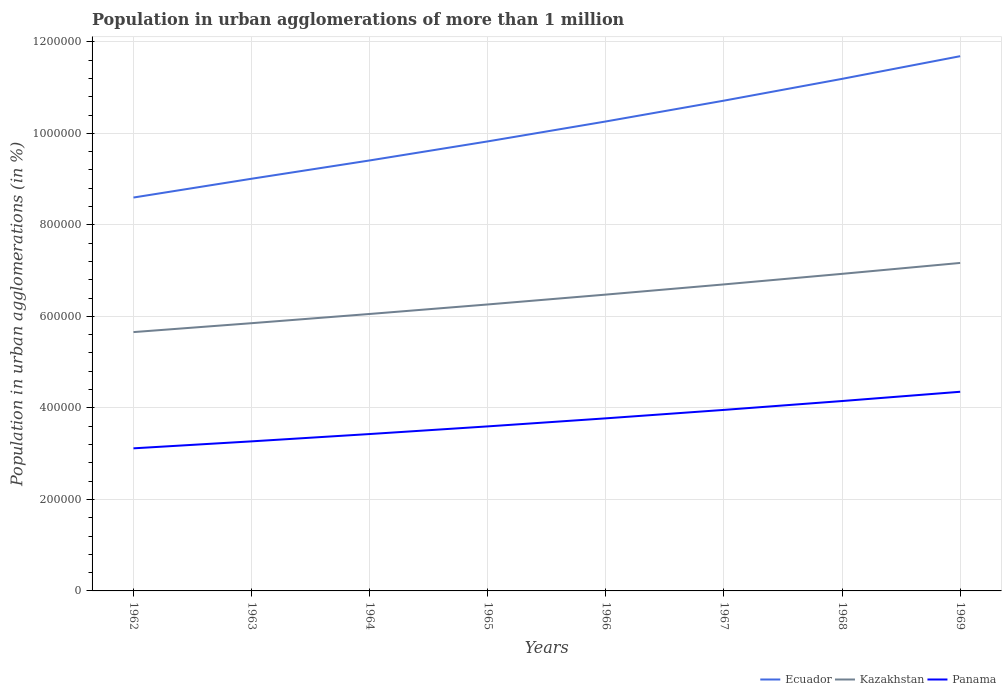Across all years, what is the maximum population in urban agglomerations in Kazakhstan?
Ensure brevity in your answer.  5.66e+05. In which year was the population in urban agglomerations in Ecuador maximum?
Your answer should be very brief. 1962. What is the total population in urban agglomerations in Kazakhstan in the graph?
Your answer should be very brief. -2.15e+04. What is the difference between the highest and the second highest population in urban agglomerations in Panama?
Give a very brief answer. 1.24e+05. What is the difference between the highest and the lowest population in urban agglomerations in Panama?
Keep it short and to the point. 4. Is the population in urban agglomerations in Panama strictly greater than the population in urban agglomerations in Kazakhstan over the years?
Your answer should be very brief. Yes. How many lines are there?
Ensure brevity in your answer.  3. How many years are there in the graph?
Provide a short and direct response. 8. Does the graph contain any zero values?
Your answer should be compact. No. Where does the legend appear in the graph?
Give a very brief answer. Bottom right. What is the title of the graph?
Your answer should be very brief. Population in urban agglomerations of more than 1 million. What is the label or title of the Y-axis?
Ensure brevity in your answer.  Population in urban agglomerations (in %). What is the Population in urban agglomerations (in %) of Ecuador in 1962?
Provide a short and direct response. 8.60e+05. What is the Population in urban agglomerations (in %) in Kazakhstan in 1962?
Make the answer very short. 5.66e+05. What is the Population in urban agglomerations (in %) of Panama in 1962?
Provide a short and direct response. 3.12e+05. What is the Population in urban agglomerations (in %) of Ecuador in 1963?
Your answer should be very brief. 9.01e+05. What is the Population in urban agglomerations (in %) in Kazakhstan in 1963?
Offer a terse response. 5.85e+05. What is the Population in urban agglomerations (in %) of Panama in 1963?
Provide a short and direct response. 3.27e+05. What is the Population in urban agglomerations (in %) of Ecuador in 1964?
Give a very brief answer. 9.41e+05. What is the Population in urban agglomerations (in %) in Kazakhstan in 1964?
Ensure brevity in your answer.  6.05e+05. What is the Population in urban agglomerations (in %) in Panama in 1964?
Ensure brevity in your answer.  3.43e+05. What is the Population in urban agglomerations (in %) in Ecuador in 1965?
Provide a short and direct response. 9.82e+05. What is the Population in urban agglomerations (in %) in Kazakhstan in 1965?
Provide a short and direct response. 6.26e+05. What is the Population in urban agglomerations (in %) in Panama in 1965?
Offer a terse response. 3.60e+05. What is the Population in urban agglomerations (in %) in Ecuador in 1966?
Your response must be concise. 1.03e+06. What is the Population in urban agglomerations (in %) of Kazakhstan in 1966?
Your answer should be very brief. 6.48e+05. What is the Population in urban agglomerations (in %) of Panama in 1966?
Offer a terse response. 3.77e+05. What is the Population in urban agglomerations (in %) of Ecuador in 1967?
Your response must be concise. 1.07e+06. What is the Population in urban agglomerations (in %) of Kazakhstan in 1967?
Your answer should be compact. 6.70e+05. What is the Population in urban agglomerations (in %) of Panama in 1967?
Provide a short and direct response. 3.96e+05. What is the Population in urban agglomerations (in %) of Ecuador in 1968?
Offer a terse response. 1.12e+06. What is the Population in urban agglomerations (in %) of Kazakhstan in 1968?
Make the answer very short. 6.93e+05. What is the Population in urban agglomerations (in %) of Panama in 1968?
Your answer should be very brief. 4.15e+05. What is the Population in urban agglomerations (in %) in Ecuador in 1969?
Offer a very short reply. 1.17e+06. What is the Population in urban agglomerations (in %) of Kazakhstan in 1969?
Give a very brief answer. 7.17e+05. What is the Population in urban agglomerations (in %) in Panama in 1969?
Make the answer very short. 4.35e+05. Across all years, what is the maximum Population in urban agglomerations (in %) of Ecuador?
Your answer should be very brief. 1.17e+06. Across all years, what is the maximum Population in urban agglomerations (in %) in Kazakhstan?
Offer a terse response. 7.17e+05. Across all years, what is the maximum Population in urban agglomerations (in %) in Panama?
Offer a terse response. 4.35e+05. Across all years, what is the minimum Population in urban agglomerations (in %) of Ecuador?
Your response must be concise. 8.60e+05. Across all years, what is the minimum Population in urban agglomerations (in %) of Kazakhstan?
Your response must be concise. 5.66e+05. Across all years, what is the minimum Population in urban agglomerations (in %) of Panama?
Provide a succinct answer. 3.12e+05. What is the total Population in urban agglomerations (in %) in Ecuador in the graph?
Provide a succinct answer. 8.07e+06. What is the total Population in urban agglomerations (in %) of Kazakhstan in the graph?
Offer a terse response. 5.11e+06. What is the total Population in urban agglomerations (in %) of Panama in the graph?
Your answer should be very brief. 2.96e+06. What is the difference between the Population in urban agglomerations (in %) of Ecuador in 1962 and that in 1963?
Your response must be concise. -4.11e+04. What is the difference between the Population in urban agglomerations (in %) of Kazakhstan in 1962 and that in 1963?
Your response must be concise. -1.95e+04. What is the difference between the Population in urban agglomerations (in %) in Panama in 1962 and that in 1963?
Provide a succinct answer. -1.52e+04. What is the difference between the Population in urban agglomerations (in %) of Ecuador in 1962 and that in 1964?
Give a very brief answer. -8.11e+04. What is the difference between the Population in urban agglomerations (in %) in Kazakhstan in 1962 and that in 1964?
Give a very brief answer. -3.96e+04. What is the difference between the Population in urban agglomerations (in %) of Panama in 1962 and that in 1964?
Provide a succinct answer. -3.12e+04. What is the difference between the Population in urban agglomerations (in %) of Ecuador in 1962 and that in 1965?
Give a very brief answer. -1.23e+05. What is the difference between the Population in urban agglomerations (in %) of Kazakhstan in 1962 and that in 1965?
Your answer should be compact. -6.04e+04. What is the difference between the Population in urban agglomerations (in %) of Panama in 1962 and that in 1965?
Your answer should be very brief. -4.80e+04. What is the difference between the Population in urban agglomerations (in %) of Ecuador in 1962 and that in 1966?
Your response must be concise. -1.66e+05. What is the difference between the Population in urban agglomerations (in %) in Kazakhstan in 1962 and that in 1966?
Keep it short and to the point. -8.19e+04. What is the difference between the Population in urban agglomerations (in %) in Panama in 1962 and that in 1966?
Give a very brief answer. -6.56e+04. What is the difference between the Population in urban agglomerations (in %) of Ecuador in 1962 and that in 1967?
Offer a very short reply. -2.12e+05. What is the difference between the Population in urban agglomerations (in %) in Kazakhstan in 1962 and that in 1967?
Offer a terse response. -1.04e+05. What is the difference between the Population in urban agglomerations (in %) in Panama in 1962 and that in 1967?
Your answer should be compact. -8.40e+04. What is the difference between the Population in urban agglomerations (in %) in Ecuador in 1962 and that in 1968?
Provide a short and direct response. -2.59e+05. What is the difference between the Population in urban agglomerations (in %) of Kazakhstan in 1962 and that in 1968?
Offer a terse response. -1.27e+05. What is the difference between the Population in urban agglomerations (in %) of Panama in 1962 and that in 1968?
Your response must be concise. -1.03e+05. What is the difference between the Population in urban agglomerations (in %) of Ecuador in 1962 and that in 1969?
Make the answer very short. -3.09e+05. What is the difference between the Population in urban agglomerations (in %) in Kazakhstan in 1962 and that in 1969?
Your answer should be compact. -1.51e+05. What is the difference between the Population in urban agglomerations (in %) of Panama in 1962 and that in 1969?
Provide a short and direct response. -1.24e+05. What is the difference between the Population in urban agglomerations (in %) of Ecuador in 1963 and that in 1964?
Give a very brief answer. -4.00e+04. What is the difference between the Population in urban agglomerations (in %) of Kazakhstan in 1963 and that in 1964?
Offer a terse response. -2.02e+04. What is the difference between the Population in urban agglomerations (in %) in Panama in 1963 and that in 1964?
Make the answer very short. -1.60e+04. What is the difference between the Population in urban agglomerations (in %) in Ecuador in 1963 and that in 1965?
Your answer should be compact. -8.16e+04. What is the difference between the Population in urban agglomerations (in %) in Kazakhstan in 1963 and that in 1965?
Offer a terse response. -4.09e+04. What is the difference between the Population in urban agglomerations (in %) in Panama in 1963 and that in 1965?
Make the answer very short. -3.27e+04. What is the difference between the Population in urban agglomerations (in %) in Ecuador in 1963 and that in 1966?
Keep it short and to the point. -1.25e+05. What is the difference between the Population in urban agglomerations (in %) in Kazakhstan in 1963 and that in 1966?
Offer a terse response. -6.25e+04. What is the difference between the Population in urban agglomerations (in %) of Panama in 1963 and that in 1966?
Keep it short and to the point. -5.03e+04. What is the difference between the Population in urban agglomerations (in %) in Ecuador in 1963 and that in 1967?
Your answer should be very brief. -1.71e+05. What is the difference between the Population in urban agglomerations (in %) of Kazakhstan in 1963 and that in 1967?
Provide a succinct answer. -8.48e+04. What is the difference between the Population in urban agglomerations (in %) of Panama in 1963 and that in 1967?
Your response must be concise. -6.88e+04. What is the difference between the Population in urban agglomerations (in %) in Ecuador in 1963 and that in 1968?
Provide a short and direct response. -2.18e+05. What is the difference between the Population in urban agglomerations (in %) of Kazakhstan in 1963 and that in 1968?
Give a very brief answer. -1.08e+05. What is the difference between the Population in urban agglomerations (in %) in Panama in 1963 and that in 1968?
Ensure brevity in your answer.  -8.81e+04. What is the difference between the Population in urban agglomerations (in %) in Ecuador in 1963 and that in 1969?
Provide a short and direct response. -2.68e+05. What is the difference between the Population in urban agglomerations (in %) in Kazakhstan in 1963 and that in 1969?
Offer a very short reply. -1.32e+05. What is the difference between the Population in urban agglomerations (in %) of Panama in 1963 and that in 1969?
Give a very brief answer. -1.08e+05. What is the difference between the Population in urban agglomerations (in %) in Ecuador in 1964 and that in 1965?
Keep it short and to the point. -4.17e+04. What is the difference between the Population in urban agglomerations (in %) in Kazakhstan in 1964 and that in 1965?
Your response must be concise. -2.08e+04. What is the difference between the Population in urban agglomerations (in %) in Panama in 1964 and that in 1965?
Give a very brief answer. -1.67e+04. What is the difference between the Population in urban agglomerations (in %) in Ecuador in 1964 and that in 1966?
Your answer should be compact. -8.52e+04. What is the difference between the Population in urban agglomerations (in %) of Kazakhstan in 1964 and that in 1966?
Provide a succinct answer. -4.23e+04. What is the difference between the Population in urban agglomerations (in %) in Panama in 1964 and that in 1966?
Your answer should be compact. -3.43e+04. What is the difference between the Population in urban agglomerations (in %) in Ecuador in 1964 and that in 1967?
Keep it short and to the point. -1.31e+05. What is the difference between the Population in urban agglomerations (in %) of Kazakhstan in 1964 and that in 1967?
Keep it short and to the point. -6.46e+04. What is the difference between the Population in urban agglomerations (in %) of Panama in 1964 and that in 1967?
Keep it short and to the point. -5.28e+04. What is the difference between the Population in urban agglomerations (in %) of Ecuador in 1964 and that in 1968?
Keep it short and to the point. -1.78e+05. What is the difference between the Population in urban agglomerations (in %) in Kazakhstan in 1964 and that in 1968?
Offer a terse response. -8.77e+04. What is the difference between the Population in urban agglomerations (in %) in Panama in 1964 and that in 1968?
Your response must be concise. -7.21e+04. What is the difference between the Population in urban agglomerations (in %) in Ecuador in 1964 and that in 1969?
Give a very brief answer. -2.28e+05. What is the difference between the Population in urban agglomerations (in %) of Kazakhstan in 1964 and that in 1969?
Provide a succinct answer. -1.11e+05. What is the difference between the Population in urban agglomerations (in %) of Panama in 1964 and that in 1969?
Offer a very short reply. -9.24e+04. What is the difference between the Population in urban agglomerations (in %) in Ecuador in 1965 and that in 1966?
Provide a short and direct response. -4.36e+04. What is the difference between the Population in urban agglomerations (in %) of Kazakhstan in 1965 and that in 1966?
Ensure brevity in your answer.  -2.15e+04. What is the difference between the Population in urban agglomerations (in %) in Panama in 1965 and that in 1966?
Your answer should be compact. -1.76e+04. What is the difference between the Population in urban agglomerations (in %) in Ecuador in 1965 and that in 1967?
Offer a terse response. -8.91e+04. What is the difference between the Population in urban agglomerations (in %) in Kazakhstan in 1965 and that in 1967?
Your response must be concise. -4.38e+04. What is the difference between the Population in urban agglomerations (in %) of Panama in 1965 and that in 1967?
Your answer should be very brief. -3.60e+04. What is the difference between the Population in urban agglomerations (in %) of Ecuador in 1965 and that in 1968?
Make the answer very short. -1.37e+05. What is the difference between the Population in urban agglomerations (in %) in Kazakhstan in 1965 and that in 1968?
Your answer should be compact. -6.69e+04. What is the difference between the Population in urban agglomerations (in %) of Panama in 1965 and that in 1968?
Provide a succinct answer. -5.54e+04. What is the difference between the Population in urban agglomerations (in %) of Ecuador in 1965 and that in 1969?
Provide a succinct answer. -1.86e+05. What is the difference between the Population in urban agglomerations (in %) of Kazakhstan in 1965 and that in 1969?
Provide a succinct answer. -9.07e+04. What is the difference between the Population in urban agglomerations (in %) in Panama in 1965 and that in 1969?
Your answer should be very brief. -7.57e+04. What is the difference between the Population in urban agglomerations (in %) in Ecuador in 1966 and that in 1967?
Offer a terse response. -4.55e+04. What is the difference between the Population in urban agglomerations (in %) of Kazakhstan in 1966 and that in 1967?
Your response must be concise. -2.23e+04. What is the difference between the Population in urban agglomerations (in %) in Panama in 1966 and that in 1967?
Your response must be concise. -1.84e+04. What is the difference between the Population in urban agglomerations (in %) of Ecuador in 1966 and that in 1968?
Your response must be concise. -9.31e+04. What is the difference between the Population in urban agglomerations (in %) in Kazakhstan in 1966 and that in 1968?
Give a very brief answer. -4.54e+04. What is the difference between the Population in urban agglomerations (in %) of Panama in 1966 and that in 1968?
Offer a very short reply. -3.78e+04. What is the difference between the Population in urban agglomerations (in %) in Ecuador in 1966 and that in 1969?
Offer a very short reply. -1.43e+05. What is the difference between the Population in urban agglomerations (in %) in Kazakhstan in 1966 and that in 1969?
Offer a terse response. -6.92e+04. What is the difference between the Population in urban agglomerations (in %) in Panama in 1966 and that in 1969?
Provide a succinct answer. -5.81e+04. What is the difference between the Population in urban agglomerations (in %) of Ecuador in 1967 and that in 1968?
Your response must be concise. -4.76e+04. What is the difference between the Population in urban agglomerations (in %) of Kazakhstan in 1967 and that in 1968?
Your answer should be compact. -2.31e+04. What is the difference between the Population in urban agglomerations (in %) of Panama in 1967 and that in 1968?
Your answer should be compact. -1.94e+04. What is the difference between the Population in urban agglomerations (in %) in Ecuador in 1967 and that in 1969?
Give a very brief answer. -9.71e+04. What is the difference between the Population in urban agglomerations (in %) in Kazakhstan in 1967 and that in 1969?
Offer a terse response. -4.69e+04. What is the difference between the Population in urban agglomerations (in %) of Panama in 1967 and that in 1969?
Keep it short and to the point. -3.96e+04. What is the difference between the Population in urban agglomerations (in %) of Ecuador in 1968 and that in 1969?
Your answer should be compact. -4.96e+04. What is the difference between the Population in urban agglomerations (in %) in Kazakhstan in 1968 and that in 1969?
Your answer should be compact. -2.38e+04. What is the difference between the Population in urban agglomerations (in %) of Panama in 1968 and that in 1969?
Your answer should be compact. -2.03e+04. What is the difference between the Population in urban agglomerations (in %) of Ecuador in 1962 and the Population in urban agglomerations (in %) of Kazakhstan in 1963?
Your answer should be very brief. 2.75e+05. What is the difference between the Population in urban agglomerations (in %) of Ecuador in 1962 and the Population in urban agglomerations (in %) of Panama in 1963?
Provide a succinct answer. 5.33e+05. What is the difference between the Population in urban agglomerations (in %) of Kazakhstan in 1962 and the Population in urban agglomerations (in %) of Panama in 1963?
Your response must be concise. 2.39e+05. What is the difference between the Population in urban agglomerations (in %) in Ecuador in 1962 and the Population in urban agglomerations (in %) in Kazakhstan in 1964?
Offer a terse response. 2.54e+05. What is the difference between the Population in urban agglomerations (in %) of Ecuador in 1962 and the Population in urban agglomerations (in %) of Panama in 1964?
Keep it short and to the point. 5.17e+05. What is the difference between the Population in urban agglomerations (in %) in Kazakhstan in 1962 and the Population in urban agglomerations (in %) in Panama in 1964?
Make the answer very short. 2.23e+05. What is the difference between the Population in urban agglomerations (in %) of Ecuador in 1962 and the Population in urban agglomerations (in %) of Kazakhstan in 1965?
Give a very brief answer. 2.34e+05. What is the difference between the Population in urban agglomerations (in %) of Ecuador in 1962 and the Population in urban agglomerations (in %) of Panama in 1965?
Provide a succinct answer. 5.00e+05. What is the difference between the Population in urban agglomerations (in %) of Kazakhstan in 1962 and the Population in urban agglomerations (in %) of Panama in 1965?
Your answer should be very brief. 2.06e+05. What is the difference between the Population in urban agglomerations (in %) in Ecuador in 1962 and the Population in urban agglomerations (in %) in Kazakhstan in 1966?
Make the answer very short. 2.12e+05. What is the difference between the Population in urban agglomerations (in %) of Ecuador in 1962 and the Population in urban agglomerations (in %) of Panama in 1966?
Your response must be concise. 4.83e+05. What is the difference between the Population in urban agglomerations (in %) of Kazakhstan in 1962 and the Population in urban agglomerations (in %) of Panama in 1966?
Your response must be concise. 1.88e+05. What is the difference between the Population in urban agglomerations (in %) of Ecuador in 1962 and the Population in urban agglomerations (in %) of Kazakhstan in 1967?
Your response must be concise. 1.90e+05. What is the difference between the Population in urban agglomerations (in %) in Ecuador in 1962 and the Population in urban agglomerations (in %) in Panama in 1967?
Your response must be concise. 4.64e+05. What is the difference between the Population in urban agglomerations (in %) in Kazakhstan in 1962 and the Population in urban agglomerations (in %) in Panama in 1967?
Offer a terse response. 1.70e+05. What is the difference between the Population in urban agglomerations (in %) of Ecuador in 1962 and the Population in urban agglomerations (in %) of Kazakhstan in 1968?
Give a very brief answer. 1.67e+05. What is the difference between the Population in urban agglomerations (in %) in Ecuador in 1962 and the Population in urban agglomerations (in %) in Panama in 1968?
Keep it short and to the point. 4.45e+05. What is the difference between the Population in urban agglomerations (in %) of Kazakhstan in 1962 and the Population in urban agglomerations (in %) of Panama in 1968?
Provide a succinct answer. 1.51e+05. What is the difference between the Population in urban agglomerations (in %) of Ecuador in 1962 and the Population in urban agglomerations (in %) of Kazakhstan in 1969?
Your answer should be very brief. 1.43e+05. What is the difference between the Population in urban agglomerations (in %) of Ecuador in 1962 and the Population in urban agglomerations (in %) of Panama in 1969?
Your response must be concise. 4.24e+05. What is the difference between the Population in urban agglomerations (in %) in Kazakhstan in 1962 and the Population in urban agglomerations (in %) in Panama in 1969?
Ensure brevity in your answer.  1.30e+05. What is the difference between the Population in urban agglomerations (in %) of Ecuador in 1963 and the Population in urban agglomerations (in %) of Kazakhstan in 1964?
Your answer should be very brief. 2.96e+05. What is the difference between the Population in urban agglomerations (in %) of Ecuador in 1963 and the Population in urban agglomerations (in %) of Panama in 1964?
Ensure brevity in your answer.  5.58e+05. What is the difference between the Population in urban agglomerations (in %) in Kazakhstan in 1963 and the Population in urban agglomerations (in %) in Panama in 1964?
Provide a short and direct response. 2.42e+05. What is the difference between the Population in urban agglomerations (in %) in Ecuador in 1963 and the Population in urban agglomerations (in %) in Kazakhstan in 1965?
Your response must be concise. 2.75e+05. What is the difference between the Population in urban agglomerations (in %) of Ecuador in 1963 and the Population in urban agglomerations (in %) of Panama in 1965?
Make the answer very short. 5.41e+05. What is the difference between the Population in urban agglomerations (in %) in Kazakhstan in 1963 and the Population in urban agglomerations (in %) in Panama in 1965?
Give a very brief answer. 2.26e+05. What is the difference between the Population in urban agglomerations (in %) in Ecuador in 1963 and the Population in urban agglomerations (in %) in Kazakhstan in 1966?
Provide a short and direct response. 2.53e+05. What is the difference between the Population in urban agglomerations (in %) of Ecuador in 1963 and the Population in urban agglomerations (in %) of Panama in 1966?
Offer a very short reply. 5.24e+05. What is the difference between the Population in urban agglomerations (in %) in Kazakhstan in 1963 and the Population in urban agglomerations (in %) in Panama in 1966?
Give a very brief answer. 2.08e+05. What is the difference between the Population in urban agglomerations (in %) in Ecuador in 1963 and the Population in urban agglomerations (in %) in Kazakhstan in 1967?
Your answer should be very brief. 2.31e+05. What is the difference between the Population in urban agglomerations (in %) in Ecuador in 1963 and the Population in urban agglomerations (in %) in Panama in 1967?
Ensure brevity in your answer.  5.05e+05. What is the difference between the Population in urban agglomerations (in %) of Kazakhstan in 1963 and the Population in urban agglomerations (in %) of Panama in 1967?
Offer a terse response. 1.89e+05. What is the difference between the Population in urban agglomerations (in %) of Ecuador in 1963 and the Population in urban agglomerations (in %) of Kazakhstan in 1968?
Your answer should be compact. 2.08e+05. What is the difference between the Population in urban agglomerations (in %) of Ecuador in 1963 and the Population in urban agglomerations (in %) of Panama in 1968?
Make the answer very short. 4.86e+05. What is the difference between the Population in urban agglomerations (in %) of Kazakhstan in 1963 and the Population in urban agglomerations (in %) of Panama in 1968?
Your answer should be very brief. 1.70e+05. What is the difference between the Population in urban agglomerations (in %) in Ecuador in 1963 and the Population in urban agglomerations (in %) in Kazakhstan in 1969?
Give a very brief answer. 1.84e+05. What is the difference between the Population in urban agglomerations (in %) in Ecuador in 1963 and the Population in urban agglomerations (in %) in Panama in 1969?
Provide a succinct answer. 4.66e+05. What is the difference between the Population in urban agglomerations (in %) of Kazakhstan in 1963 and the Population in urban agglomerations (in %) of Panama in 1969?
Provide a succinct answer. 1.50e+05. What is the difference between the Population in urban agglomerations (in %) of Ecuador in 1964 and the Population in urban agglomerations (in %) of Kazakhstan in 1965?
Make the answer very short. 3.15e+05. What is the difference between the Population in urban agglomerations (in %) in Ecuador in 1964 and the Population in urban agglomerations (in %) in Panama in 1965?
Provide a succinct answer. 5.81e+05. What is the difference between the Population in urban agglomerations (in %) in Kazakhstan in 1964 and the Population in urban agglomerations (in %) in Panama in 1965?
Provide a short and direct response. 2.46e+05. What is the difference between the Population in urban agglomerations (in %) in Ecuador in 1964 and the Population in urban agglomerations (in %) in Kazakhstan in 1966?
Provide a short and direct response. 2.93e+05. What is the difference between the Population in urban agglomerations (in %) of Ecuador in 1964 and the Population in urban agglomerations (in %) of Panama in 1966?
Ensure brevity in your answer.  5.64e+05. What is the difference between the Population in urban agglomerations (in %) of Kazakhstan in 1964 and the Population in urban agglomerations (in %) of Panama in 1966?
Your answer should be compact. 2.28e+05. What is the difference between the Population in urban agglomerations (in %) in Ecuador in 1964 and the Population in urban agglomerations (in %) in Kazakhstan in 1967?
Give a very brief answer. 2.71e+05. What is the difference between the Population in urban agglomerations (in %) in Ecuador in 1964 and the Population in urban agglomerations (in %) in Panama in 1967?
Your answer should be very brief. 5.45e+05. What is the difference between the Population in urban agglomerations (in %) in Kazakhstan in 1964 and the Population in urban agglomerations (in %) in Panama in 1967?
Make the answer very short. 2.10e+05. What is the difference between the Population in urban agglomerations (in %) in Ecuador in 1964 and the Population in urban agglomerations (in %) in Kazakhstan in 1968?
Keep it short and to the point. 2.48e+05. What is the difference between the Population in urban agglomerations (in %) of Ecuador in 1964 and the Population in urban agglomerations (in %) of Panama in 1968?
Your response must be concise. 5.26e+05. What is the difference between the Population in urban agglomerations (in %) of Kazakhstan in 1964 and the Population in urban agglomerations (in %) of Panama in 1968?
Give a very brief answer. 1.90e+05. What is the difference between the Population in urban agglomerations (in %) of Ecuador in 1964 and the Population in urban agglomerations (in %) of Kazakhstan in 1969?
Your answer should be very brief. 2.24e+05. What is the difference between the Population in urban agglomerations (in %) in Ecuador in 1964 and the Population in urban agglomerations (in %) in Panama in 1969?
Offer a terse response. 5.06e+05. What is the difference between the Population in urban agglomerations (in %) of Kazakhstan in 1964 and the Population in urban agglomerations (in %) of Panama in 1969?
Offer a terse response. 1.70e+05. What is the difference between the Population in urban agglomerations (in %) in Ecuador in 1965 and the Population in urban agglomerations (in %) in Kazakhstan in 1966?
Keep it short and to the point. 3.35e+05. What is the difference between the Population in urban agglomerations (in %) in Ecuador in 1965 and the Population in urban agglomerations (in %) in Panama in 1966?
Ensure brevity in your answer.  6.05e+05. What is the difference between the Population in urban agglomerations (in %) in Kazakhstan in 1965 and the Population in urban agglomerations (in %) in Panama in 1966?
Your answer should be very brief. 2.49e+05. What is the difference between the Population in urban agglomerations (in %) in Ecuador in 1965 and the Population in urban agglomerations (in %) in Kazakhstan in 1967?
Ensure brevity in your answer.  3.13e+05. What is the difference between the Population in urban agglomerations (in %) of Ecuador in 1965 and the Population in urban agglomerations (in %) of Panama in 1967?
Make the answer very short. 5.87e+05. What is the difference between the Population in urban agglomerations (in %) of Kazakhstan in 1965 and the Population in urban agglomerations (in %) of Panama in 1967?
Give a very brief answer. 2.30e+05. What is the difference between the Population in urban agglomerations (in %) in Ecuador in 1965 and the Population in urban agglomerations (in %) in Kazakhstan in 1968?
Keep it short and to the point. 2.89e+05. What is the difference between the Population in urban agglomerations (in %) of Ecuador in 1965 and the Population in urban agglomerations (in %) of Panama in 1968?
Keep it short and to the point. 5.67e+05. What is the difference between the Population in urban agglomerations (in %) in Kazakhstan in 1965 and the Population in urban agglomerations (in %) in Panama in 1968?
Offer a very short reply. 2.11e+05. What is the difference between the Population in urban agglomerations (in %) of Ecuador in 1965 and the Population in urban agglomerations (in %) of Kazakhstan in 1969?
Offer a terse response. 2.66e+05. What is the difference between the Population in urban agglomerations (in %) in Ecuador in 1965 and the Population in urban agglomerations (in %) in Panama in 1969?
Offer a terse response. 5.47e+05. What is the difference between the Population in urban agglomerations (in %) of Kazakhstan in 1965 and the Population in urban agglomerations (in %) of Panama in 1969?
Your answer should be compact. 1.91e+05. What is the difference between the Population in urban agglomerations (in %) of Ecuador in 1966 and the Population in urban agglomerations (in %) of Kazakhstan in 1967?
Offer a very short reply. 3.56e+05. What is the difference between the Population in urban agglomerations (in %) in Ecuador in 1966 and the Population in urban agglomerations (in %) in Panama in 1967?
Keep it short and to the point. 6.30e+05. What is the difference between the Population in urban agglomerations (in %) of Kazakhstan in 1966 and the Population in urban agglomerations (in %) of Panama in 1967?
Offer a terse response. 2.52e+05. What is the difference between the Population in urban agglomerations (in %) of Ecuador in 1966 and the Population in urban agglomerations (in %) of Kazakhstan in 1968?
Give a very brief answer. 3.33e+05. What is the difference between the Population in urban agglomerations (in %) of Ecuador in 1966 and the Population in urban agglomerations (in %) of Panama in 1968?
Ensure brevity in your answer.  6.11e+05. What is the difference between the Population in urban agglomerations (in %) of Kazakhstan in 1966 and the Population in urban agglomerations (in %) of Panama in 1968?
Ensure brevity in your answer.  2.33e+05. What is the difference between the Population in urban agglomerations (in %) in Ecuador in 1966 and the Population in urban agglomerations (in %) in Kazakhstan in 1969?
Make the answer very short. 3.09e+05. What is the difference between the Population in urban agglomerations (in %) in Ecuador in 1966 and the Population in urban agglomerations (in %) in Panama in 1969?
Provide a succinct answer. 5.91e+05. What is the difference between the Population in urban agglomerations (in %) of Kazakhstan in 1966 and the Population in urban agglomerations (in %) of Panama in 1969?
Make the answer very short. 2.12e+05. What is the difference between the Population in urban agglomerations (in %) in Ecuador in 1967 and the Population in urban agglomerations (in %) in Kazakhstan in 1968?
Your answer should be compact. 3.79e+05. What is the difference between the Population in urban agglomerations (in %) in Ecuador in 1967 and the Population in urban agglomerations (in %) in Panama in 1968?
Give a very brief answer. 6.56e+05. What is the difference between the Population in urban agglomerations (in %) in Kazakhstan in 1967 and the Population in urban agglomerations (in %) in Panama in 1968?
Your answer should be compact. 2.55e+05. What is the difference between the Population in urban agglomerations (in %) in Ecuador in 1967 and the Population in urban agglomerations (in %) in Kazakhstan in 1969?
Your response must be concise. 3.55e+05. What is the difference between the Population in urban agglomerations (in %) in Ecuador in 1967 and the Population in urban agglomerations (in %) in Panama in 1969?
Make the answer very short. 6.36e+05. What is the difference between the Population in urban agglomerations (in %) of Kazakhstan in 1967 and the Population in urban agglomerations (in %) of Panama in 1969?
Offer a terse response. 2.35e+05. What is the difference between the Population in urban agglomerations (in %) of Ecuador in 1968 and the Population in urban agglomerations (in %) of Kazakhstan in 1969?
Your answer should be very brief. 4.02e+05. What is the difference between the Population in urban agglomerations (in %) of Ecuador in 1968 and the Population in urban agglomerations (in %) of Panama in 1969?
Your answer should be very brief. 6.84e+05. What is the difference between the Population in urban agglomerations (in %) of Kazakhstan in 1968 and the Population in urban agglomerations (in %) of Panama in 1969?
Your response must be concise. 2.58e+05. What is the average Population in urban agglomerations (in %) of Ecuador per year?
Give a very brief answer. 1.01e+06. What is the average Population in urban agglomerations (in %) in Kazakhstan per year?
Your answer should be compact. 6.39e+05. What is the average Population in urban agglomerations (in %) of Panama per year?
Your answer should be very brief. 3.70e+05. In the year 1962, what is the difference between the Population in urban agglomerations (in %) in Ecuador and Population in urban agglomerations (in %) in Kazakhstan?
Your answer should be compact. 2.94e+05. In the year 1962, what is the difference between the Population in urban agglomerations (in %) in Ecuador and Population in urban agglomerations (in %) in Panama?
Make the answer very short. 5.48e+05. In the year 1962, what is the difference between the Population in urban agglomerations (in %) in Kazakhstan and Population in urban agglomerations (in %) in Panama?
Make the answer very short. 2.54e+05. In the year 1963, what is the difference between the Population in urban agglomerations (in %) in Ecuador and Population in urban agglomerations (in %) in Kazakhstan?
Your answer should be compact. 3.16e+05. In the year 1963, what is the difference between the Population in urban agglomerations (in %) in Ecuador and Population in urban agglomerations (in %) in Panama?
Give a very brief answer. 5.74e+05. In the year 1963, what is the difference between the Population in urban agglomerations (in %) in Kazakhstan and Population in urban agglomerations (in %) in Panama?
Provide a short and direct response. 2.58e+05. In the year 1964, what is the difference between the Population in urban agglomerations (in %) in Ecuador and Population in urban agglomerations (in %) in Kazakhstan?
Make the answer very short. 3.35e+05. In the year 1964, what is the difference between the Population in urban agglomerations (in %) of Ecuador and Population in urban agglomerations (in %) of Panama?
Your answer should be very brief. 5.98e+05. In the year 1964, what is the difference between the Population in urban agglomerations (in %) in Kazakhstan and Population in urban agglomerations (in %) in Panama?
Provide a short and direct response. 2.62e+05. In the year 1965, what is the difference between the Population in urban agglomerations (in %) of Ecuador and Population in urban agglomerations (in %) of Kazakhstan?
Ensure brevity in your answer.  3.56e+05. In the year 1965, what is the difference between the Population in urban agglomerations (in %) of Ecuador and Population in urban agglomerations (in %) of Panama?
Give a very brief answer. 6.23e+05. In the year 1965, what is the difference between the Population in urban agglomerations (in %) in Kazakhstan and Population in urban agglomerations (in %) in Panama?
Provide a succinct answer. 2.66e+05. In the year 1966, what is the difference between the Population in urban agglomerations (in %) in Ecuador and Population in urban agglomerations (in %) in Kazakhstan?
Offer a terse response. 3.78e+05. In the year 1966, what is the difference between the Population in urban agglomerations (in %) in Ecuador and Population in urban agglomerations (in %) in Panama?
Your response must be concise. 6.49e+05. In the year 1966, what is the difference between the Population in urban agglomerations (in %) in Kazakhstan and Population in urban agglomerations (in %) in Panama?
Give a very brief answer. 2.70e+05. In the year 1967, what is the difference between the Population in urban agglomerations (in %) of Ecuador and Population in urban agglomerations (in %) of Kazakhstan?
Make the answer very short. 4.02e+05. In the year 1967, what is the difference between the Population in urban agglomerations (in %) of Ecuador and Population in urban agglomerations (in %) of Panama?
Keep it short and to the point. 6.76e+05. In the year 1967, what is the difference between the Population in urban agglomerations (in %) in Kazakhstan and Population in urban agglomerations (in %) in Panama?
Make the answer very short. 2.74e+05. In the year 1968, what is the difference between the Population in urban agglomerations (in %) of Ecuador and Population in urban agglomerations (in %) of Kazakhstan?
Provide a succinct answer. 4.26e+05. In the year 1968, what is the difference between the Population in urban agglomerations (in %) of Ecuador and Population in urban agglomerations (in %) of Panama?
Your response must be concise. 7.04e+05. In the year 1968, what is the difference between the Population in urban agglomerations (in %) of Kazakhstan and Population in urban agglomerations (in %) of Panama?
Ensure brevity in your answer.  2.78e+05. In the year 1969, what is the difference between the Population in urban agglomerations (in %) in Ecuador and Population in urban agglomerations (in %) in Kazakhstan?
Provide a short and direct response. 4.52e+05. In the year 1969, what is the difference between the Population in urban agglomerations (in %) of Ecuador and Population in urban agglomerations (in %) of Panama?
Make the answer very short. 7.33e+05. In the year 1969, what is the difference between the Population in urban agglomerations (in %) in Kazakhstan and Population in urban agglomerations (in %) in Panama?
Ensure brevity in your answer.  2.81e+05. What is the ratio of the Population in urban agglomerations (in %) of Ecuador in 1962 to that in 1963?
Ensure brevity in your answer.  0.95. What is the ratio of the Population in urban agglomerations (in %) of Kazakhstan in 1962 to that in 1963?
Your answer should be very brief. 0.97. What is the ratio of the Population in urban agglomerations (in %) in Panama in 1962 to that in 1963?
Ensure brevity in your answer.  0.95. What is the ratio of the Population in urban agglomerations (in %) in Ecuador in 1962 to that in 1964?
Keep it short and to the point. 0.91. What is the ratio of the Population in urban agglomerations (in %) of Kazakhstan in 1962 to that in 1964?
Offer a very short reply. 0.93. What is the ratio of the Population in urban agglomerations (in %) in Panama in 1962 to that in 1964?
Your answer should be very brief. 0.91. What is the ratio of the Population in urban agglomerations (in %) of Ecuador in 1962 to that in 1965?
Provide a succinct answer. 0.88. What is the ratio of the Population in urban agglomerations (in %) of Kazakhstan in 1962 to that in 1965?
Offer a terse response. 0.9. What is the ratio of the Population in urban agglomerations (in %) in Panama in 1962 to that in 1965?
Keep it short and to the point. 0.87. What is the ratio of the Population in urban agglomerations (in %) in Ecuador in 1962 to that in 1966?
Give a very brief answer. 0.84. What is the ratio of the Population in urban agglomerations (in %) of Kazakhstan in 1962 to that in 1966?
Provide a succinct answer. 0.87. What is the ratio of the Population in urban agglomerations (in %) in Panama in 1962 to that in 1966?
Your answer should be very brief. 0.83. What is the ratio of the Population in urban agglomerations (in %) in Ecuador in 1962 to that in 1967?
Your response must be concise. 0.8. What is the ratio of the Population in urban agglomerations (in %) of Kazakhstan in 1962 to that in 1967?
Offer a terse response. 0.84. What is the ratio of the Population in urban agglomerations (in %) in Panama in 1962 to that in 1967?
Your response must be concise. 0.79. What is the ratio of the Population in urban agglomerations (in %) of Ecuador in 1962 to that in 1968?
Your response must be concise. 0.77. What is the ratio of the Population in urban agglomerations (in %) of Kazakhstan in 1962 to that in 1968?
Your response must be concise. 0.82. What is the ratio of the Population in urban agglomerations (in %) in Panama in 1962 to that in 1968?
Your answer should be compact. 0.75. What is the ratio of the Population in urban agglomerations (in %) in Ecuador in 1962 to that in 1969?
Provide a short and direct response. 0.74. What is the ratio of the Population in urban agglomerations (in %) of Kazakhstan in 1962 to that in 1969?
Offer a terse response. 0.79. What is the ratio of the Population in urban agglomerations (in %) of Panama in 1962 to that in 1969?
Ensure brevity in your answer.  0.72. What is the ratio of the Population in urban agglomerations (in %) in Ecuador in 1963 to that in 1964?
Provide a short and direct response. 0.96. What is the ratio of the Population in urban agglomerations (in %) of Kazakhstan in 1963 to that in 1964?
Make the answer very short. 0.97. What is the ratio of the Population in urban agglomerations (in %) in Panama in 1963 to that in 1964?
Offer a very short reply. 0.95. What is the ratio of the Population in urban agglomerations (in %) of Ecuador in 1963 to that in 1965?
Provide a succinct answer. 0.92. What is the ratio of the Population in urban agglomerations (in %) of Kazakhstan in 1963 to that in 1965?
Make the answer very short. 0.93. What is the ratio of the Population in urban agglomerations (in %) of Panama in 1963 to that in 1965?
Your response must be concise. 0.91. What is the ratio of the Population in urban agglomerations (in %) in Ecuador in 1963 to that in 1966?
Offer a very short reply. 0.88. What is the ratio of the Population in urban agglomerations (in %) in Kazakhstan in 1963 to that in 1966?
Give a very brief answer. 0.9. What is the ratio of the Population in urban agglomerations (in %) of Panama in 1963 to that in 1966?
Provide a succinct answer. 0.87. What is the ratio of the Population in urban agglomerations (in %) in Ecuador in 1963 to that in 1967?
Your answer should be very brief. 0.84. What is the ratio of the Population in urban agglomerations (in %) of Kazakhstan in 1963 to that in 1967?
Your response must be concise. 0.87. What is the ratio of the Population in urban agglomerations (in %) of Panama in 1963 to that in 1967?
Ensure brevity in your answer.  0.83. What is the ratio of the Population in urban agglomerations (in %) of Ecuador in 1963 to that in 1968?
Offer a terse response. 0.8. What is the ratio of the Population in urban agglomerations (in %) in Kazakhstan in 1963 to that in 1968?
Your response must be concise. 0.84. What is the ratio of the Population in urban agglomerations (in %) of Panama in 1963 to that in 1968?
Offer a terse response. 0.79. What is the ratio of the Population in urban agglomerations (in %) of Ecuador in 1963 to that in 1969?
Keep it short and to the point. 0.77. What is the ratio of the Population in urban agglomerations (in %) in Kazakhstan in 1963 to that in 1969?
Give a very brief answer. 0.82. What is the ratio of the Population in urban agglomerations (in %) in Panama in 1963 to that in 1969?
Provide a succinct answer. 0.75. What is the ratio of the Population in urban agglomerations (in %) of Ecuador in 1964 to that in 1965?
Ensure brevity in your answer.  0.96. What is the ratio of the Population in urban agglomerations (in %) of Kazakhstan in 1964 to that in 1965?
Give a very brief answer. 0.97. What is the ratio of the Population in urban agglomerations (in %) of Panama in 1964 to that in 1965?
Offer a very short reply. 0.95. What is the ratio of the Population in urban agglomerations (in %) of Ecuador in 1964 to that in 1966?
Keep it short and to the point. 0.92. What is the ratio of the Population in urban agglomerations (in %) in Kazakhstan in 1964 to that in 1966?
Your answer should be compact. 0.93. What is the ratio of the Population in urban agglomerations (in %) in Panama in 1964 to that in 1966?
Ensure brevity in your answer.  0.91. What is the ratio of the Population in urban agglomerations (in %) of Ecuador in 1964 to that in 1967?
Give a very brief answer. 0.88. What is the ratio of the Population in urban agglomerations (in %) of Kazakhstan in 1964 to that in 1967?
Your response must be concise. 0.9. What is the ratio of the Population in urban agglomerations (in %) of Panama in 1964 to that in 1967?
Your answer should be very brief. 0.87. What is the ratio of the Population in urban agglomerations (in %) of Ecuador in 1964 to that in 1968?
Offer a very short reply. 0.84. What is the ratio of the Population in urban agglomerations (in %) in Kazakhstan in 1964 to that in 1968?
Your response must be concise. 0.87. What is the ratio of the Population in urban agglomerations (in %) in Panama in 1964 to that in 1968?
Your answer should be very brief. 0.83. What is the ratio of the Population in urban agglomerations (in %) in Ecuador in 1964 to that in 1969?
Offer a terse response. 0.81. What is the ratio of the Population in urban agglomerations (in %) of Kazakhstan in 1964 to that in 1969?
Provide a succinct answer. 0.84. What is the ratio of the Population in urban agglomerations (in %) in Panama in 1964 to that in 1969?
Keep it short and to the point. 0.79. What is the ratio of the Population in urban agglomerations (in %) in Ecuador in 1965 to that in 1966?
Offer a terse response. 0.96. What is the ratio of the Population in urban agglomerations (in %) in Kazakhstan in 1965 to that in 1966?
Your answer should be very brief. 0.97. What is the ratio of the Population in urban agglomerations (in %) of Panama in 1965 to that in 1966?
Provide a succinct answer. 0.95. What is the ratio of the Population in urban agglomerations (in %) in Ecuador in 1965 to that in 1967?
Provide a short and direct response. 0.92. What is the ratio of the Population in urban agglomerations (in %) of Kazakhstan in 1965 to that in 1967?
Your answer should be compact. 0.93. What is the ratio of the Population in urban agglomerations (in %) of Panama in 1965 to that in 1967?
Your answer should be very brief. 0.91. What is the ratio of the Population in urban agglomerations (in %) in Ecuador in 1965 to that in 1968?
Provide a succinct answer. 0.88. What is the ratio of the Population in urban agglomerations (in %) in Kazakhstan in 1965 to that in 1968?
Give a very brief answer. 0.9. What is the ratio of the Population in urban agglomerations (in %) of Panama in 1965 to that in 1968?
Provide a short and direct response. 0.87. What is the ratio of the Population in urban agglomerations (in %) in Ecuador in 1965 to that in 1969?
Provide a short and direct response. 0.84. What is the ratio of the Population in urban agglomerations (in %) in Kazakhstan in 1965 to that in 1969?
Ensure brevity in your answer.  0.87. What is the ratio of the Population in urban agglomerations (in %) in Panama in 1965 to that in 1969?
Make the answer very short. 0.83. What is the ratio of the Population in urban agglomerations (in %) of Ecuador in 1966 to that in 1967?
Your answer should be very brief. 0.96. What is the ratio of the Population in urban agglomerations (in %) in Kazakhstan in 1966 to that in 1967?
Offer a very short reply. 0.97. What is the ratio of the Population in urban agglomerations (in %) of Panama in 1966 to that in 1967?
Your answer should be very brief. 0.95. What is the ratio of the Population in urban agglomerations (in %) in Ecuador in 1966 to that in 1968?
Keep it short and to the point. 0.92. What is the ratio of the Population in urban agglomerations (in %) of Kazakhstan in 1966 to that in 1968?
Your response must be concise. 0.93. What is the ratio of the Population in urban agglomerations (in %) in Panama in 1966 to that in 1968?
Offer a very short reply. 0.91. What is the ratio of the Population in urban agglomerations (in %) of Ecuador in 1966 to that in 1969?
Offer a terse response. 0.88. What is the ratio of the Population in urban agglomerations (in %) of Kazakhstan in 1966 to that in 1969?
Make the answer very short. 0.9. What is the ratio of the Population in urban agglomerations (in %) in Panama in 1966 to that in 1969?
Ensure brevity in your answer.  0.87. What is the ratio of the Population in urban agglomerations (in %) of Ecuador in 1967 to that in 1968?
Make the answer very short. 0.96. What is the ratio of the Population in urban agglomerations (in %) of Kazakhstan in 1967 to that in 1968?
Provide a short and direct response. 0.97. What is the ratio of the Population in urban agglomerations (in %) of Panama in 1967 to that in 1968?
Give a very brief answer. 0.95. What is the ratio of the Population in urban agglomerations (in %) in Ecuador in 1967 to that in 1969?
Your answer should be very brief. 0.92. What is the ratio of the Population in urban agglomerations (in %) in Kazakhstan in 1967 to that in 1969?
Provide a short and direct response. 0.93. What is the ratio of the Population in urban agglomerations (in %) in Panama in 1967 to that in 1969?
Provide a succinct answer. 0.91. What is the ratio of the Population in urban agglomerations (in %) of Ecuador in 1968 to that in 1969?
Your answer should be compact. 0.96. What is the ratio of the Population in urban agglomerations (in %) in Kazakhstan in 1968 to that in 1969?
Your answer should be very brief. 0.97. What is the ratio of the Population in urban agglomerations (in %) in Panama in 1968 to that in 1969?
Provide a succinct answer. 0.95. What is the difference between the highest and the second highest Population in urban agglomerations (in %) in Ecuador?
Keep it short and to the point. 4.96e+04. What is the difference between the highest and the second highest Population in urban agglomerations (in %) in Kazakhstan?
Make the answer very short. 2.38e+04. What is the difference between the highest and the second highest Population in urban agglomerations (in %) in Panama?
Your answer should be compact. 2.03e+04. What is the difference between the highest and the lowest Population in urban agglomerations (in %) in Ecuador?
Provide a short and direct response. 3.09e+05. What is the difference between the highest and the lowest Population in urban agglomerations (in %) in Kazakhstan?
Your answer should be compact. 1.51e+05. What is the difference between the highest and the lowest Population in urban agglomerations (in %) of Panama?
Your response must be concise. 1.24e+05. 